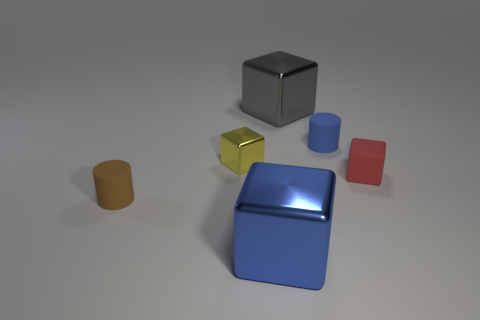What shape is the shiny thing in front of the rubber thing left of the small blue object?
Provide a succinct answer. Cube. There is a yellow metallic block; what number of small matte cylinders are behind it?
Your answer should be compact. 1. Are there any small things made of the same material as the blue block?
Offer a very short reply. Yes. What is the material of the yellow object that is the same size as the blue matte cylinder?
Offer a terse response. Metal. There is a block that is to the left of the red thing and in front of the small yellow cube; what size is it?
Give a very brief answer. Large. What is the color of the tiny thing that is both to the right of the small metallic thing and behind the tiny red matte cube?
Give a very brief answer. Blue. Is the number of shiny objects to the left of the yellow metallic block less than the number of yellow things that are behind the tiny brown rubber cylinder?
Provide a short and direct response. Yes. How many brown things have the same shape as the small red matte thing?
Ensure brevity in your answer.  0. The yellow block that is made of the same material as the gray thing is what size?
Your response must be concise. Small. What is the color of the metallic cube that is right of the large thing to the left of the gray cube?
Provide a succinct answer. Gray. 